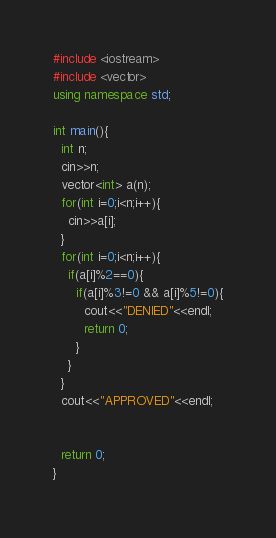<code> <loc_0><loc_0><loc_500><loc_500><_C++_>#include <iostream>
#include <vector>
using namespace std;

int main(){
  int n;
  cin>>n;
  vector<int> a(n);
  for(int i=0;i<n;i++){
    cin>>a[i];
  }
  for(int i=0;i<n;i++){    
    if(a[i]%2==0){
      if(a[i]%3!=0 && a[i]%5!=0){
        cout<<"DENIED"<<endl;
        return 0;
      }
    }
  }  
  cout<<"APPROVED"<<endl;
   
  
  return 0;
}
</code> 